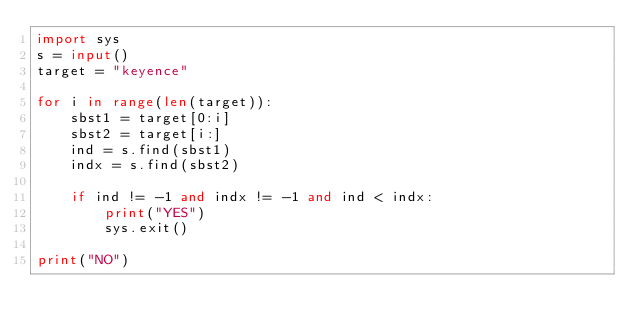Convert code to text. <code><loc_0><loc_0><loc_500><loc_500><_Python_>import sys
s = input()
target = "keyence"

for i in range(len(target)):
    sbst1 = target[0:i]
    sbst2 = target[i:]
    ind = s.find(sbst1)
    indx = s.find(sbst2)

    if ind != -1 and indx != -1 and ind < indx:
        print("YES")
        sys.exit()

print("NO")</code> 